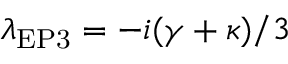<formula> <loc_0><loc_0><loc_500><loc_500>\lambda _ { E P 3 } = - i ( \gamma + \kappa ) / 3</formula> 